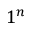Convert formula to latex. <formula><loc_0><loc_0><loc_500><loc_500>1 ^ { n }</formula> 